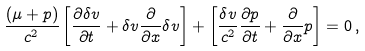<formula> <loc_0><loc_0><loc_500><loc_500>\frac { \left ( \mu + p \right ) } { c ^ { 2 } } \left [ \frac { \partial \delta v } { \partial t } + \delta v \frac { \partial } { \partial x } \delta v \right ] + \left [ \frac { \delta v } { c ^ { 2 } } \frac { \partial p } { \partial t } + \frac { \partial } { \partial x } p \right ] = 0 \, ,</formula> 